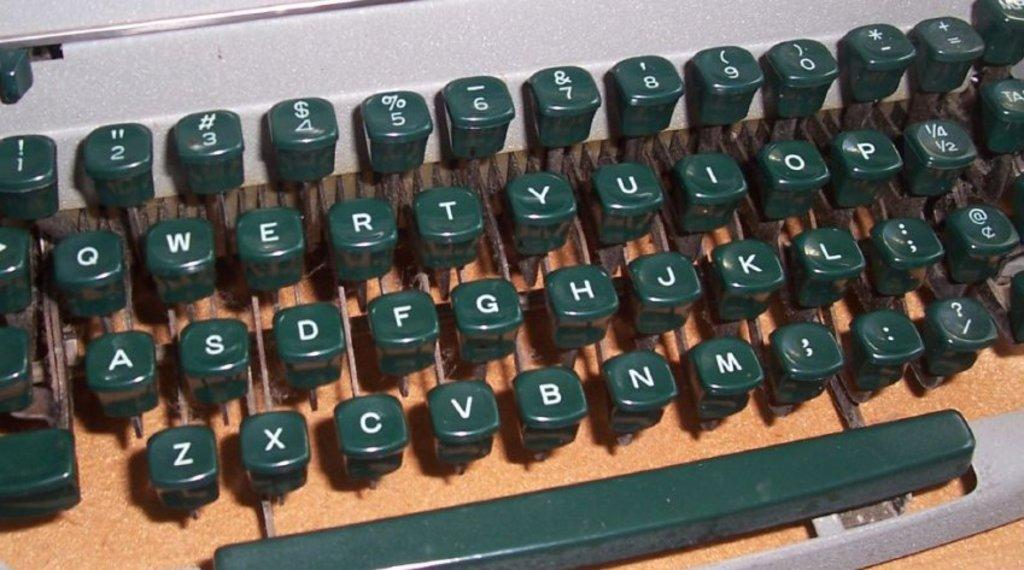<image>
Give a short and clear explanation of the subsequent image. A typewriter keyboard with the letters of the alphabet on it. 